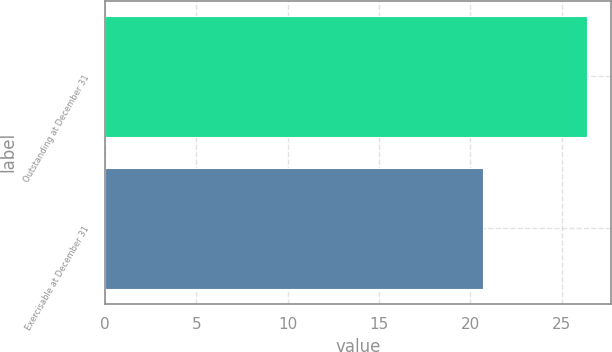Convert chart. <chart><loc_0><loc_0><loc_500><loc_500><bar_chart><fcel>Outstanding at December 31<fcel>Exercisable at December 31<nl><fcel>26.39<fcel>20.68<nl></chart> 